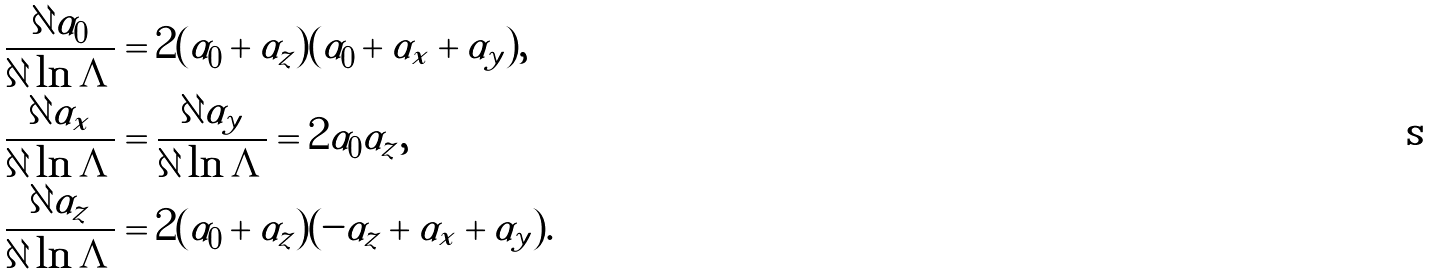Convert formula to latex. <formula><loc_0><loc_0><loc_500><loc_500>\frac { \partial \alpha _ { 0 } } { \partial \ln \Lambda } & = 2 ( \alpha _ { 0 } + \alpha _ { z } ) ( \alpha _ { 0 } + \alpha _ { x } + \alpha _ { y } ) , \\ \frac { \partial \alpha _ { x } } { \partial \ln \Lambda } & = \frac { \partial \alpha _ { y } } { \partial \ln \Lambda } = 2 \alpha _ { 0 } \alpha _ { z } , \\ \frac { \partial \alpha _ { z } } { \partial \ln \Lambda } & = 2 ( \alpha _ { 0 } + \alpha _ { z } ) ( - \alpha _ { z } + \alpha _ { x } + \alpha _ { y } ) .</formula> 